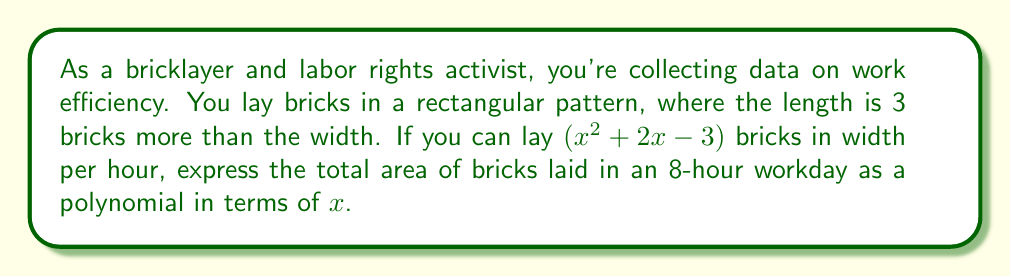Solve this math problem. Let's approach this step-by-step:

1) First, let's define our variables:
   - Width of the rectangle: $(x^2 + 2x - 3)$ bricks
   - Length of the rectangle: $(x^2 + 2x - 3) + 3 = x^2 + 2x$ bricks

2) The area of a rectangle is given by length × width. So for one hour, the area is:
   $$(x^2 + 2x)(x^2 + 2x - 3)$$

3) Let's expand this polynomial:
   $$(x^2 + 2x)(x^2 + 2x - 3) = x^4 + 2x^3 - 3x^2 + 2x^3 + 4x^2 - 6x$$
   $$= x^4 + 4x^3 + x^2 - 6x$$

4) This is the area for one hour. For an 8-hour workday, we multiply this by 8:
   $$8(x^4 + 4x^3 + x^2 - 6x)$$

5) Distributing the 8:
   $$8x^4 + 32x^3 + 8x^2 - 48x$$

This polynomial represents the total area of bricks laid in an 8-hour workday.
Answer: $8x^4 + 32x^3 + 8x^2 - 48x$ 